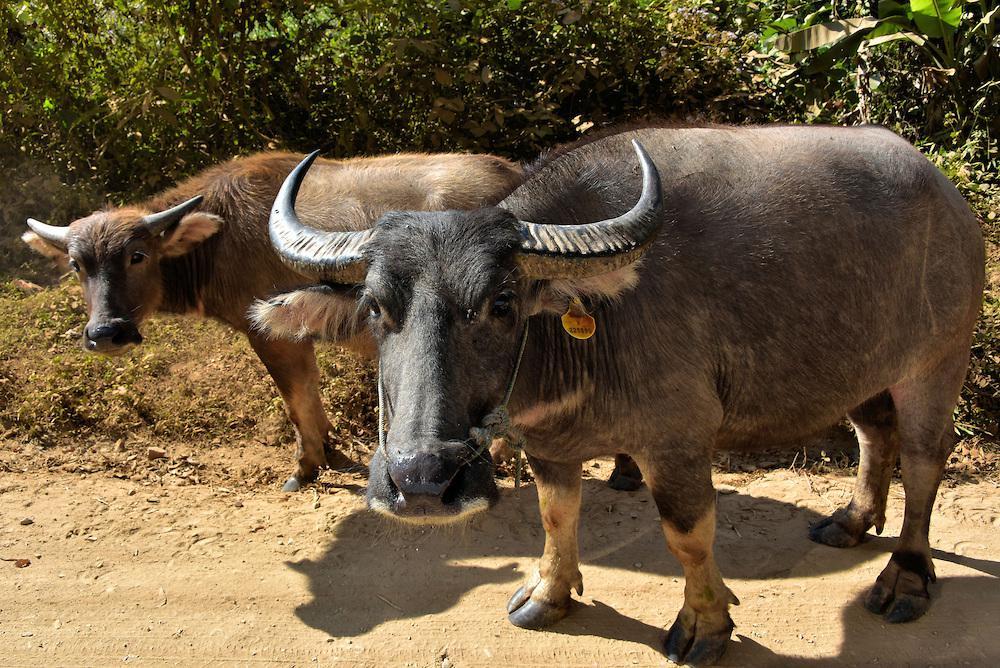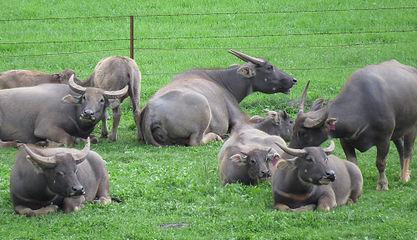The first image is the image on the left, the second image is the image on the right. Considering the images on both sides, is "There is at one man with a blue shirt in the middle of at least 10 horned oxes." valid? Answer yes or no. No. The first image is the image on the left, the second image is the image on the right. Considering the images on both sides, is "A person wearing bright blue is in the middle of a large group of oxen in one image." valid? Answer yes or no. No. 